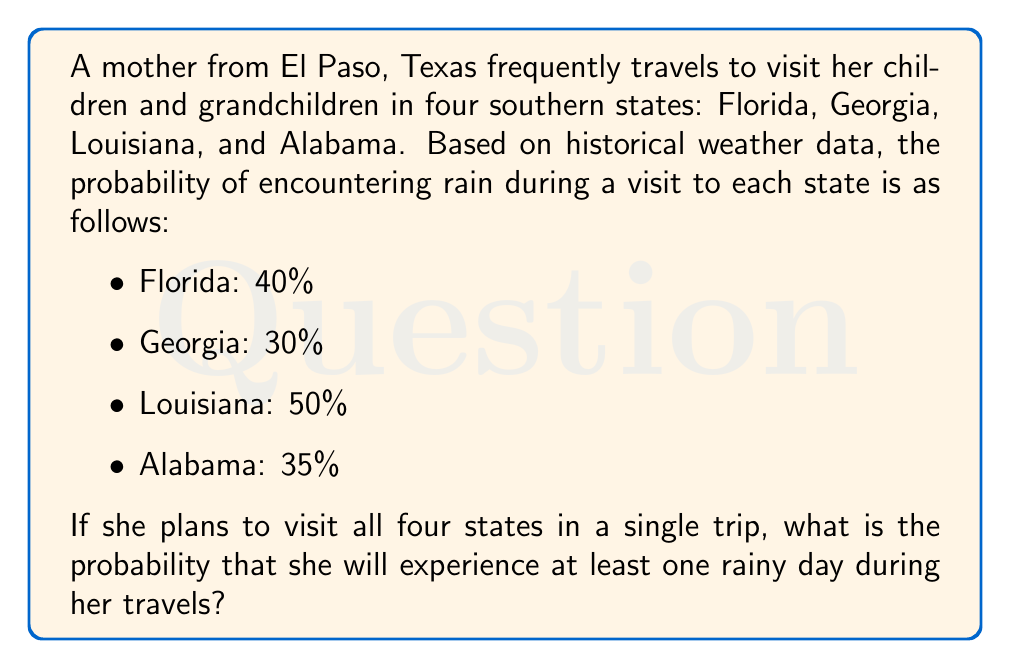Give your solution to this math problem. To solve this problem, we'll use the complement rule of probability. Instead of calculating the probability of experiencing at least one rainy day, we'll calculate the probability of experiencing no rainy days and then subtract that from 1.

Let's break it down step-by-step:

1. Calculate the probability of no rain in each state:
   - Florida: $1 - 0.40 = 0.60$
   - Georgia: $1 - 0.30 = 0.70$
   - Louisiana: $1 - 0.50 = 0.50$
   - Alabama: $1 - 0.35 = 0.65$

2. To have no rainy days during the entire trip, it must not rain in any of the states. Since these are independent events, we multiply the probabilities:

   $P(\text{no rain}) = 0.60 \times 0.70 \times 0.50 \times 0.65$

3. Calculate this probability:
   
   $P(\text{no rain}) = 0.1365$ or $13.65\%$

4. Now, use the complement rule to find the probability of at least one rainy day:

   $P(\text{at least one rainy day}) = 1 - P(\text{no rain})$
   $P(\text{at least one rainy day}) = 1 - 0.1365 = 0.8635$

Therefore, the probability of experiencing at least one rainy day during her travels is 0.8635 or 86.35%.
Answer: The probability that the mother will experience at least one rainy day during her travels to the four southern states is $0.8635$ or $86.35\%$. 